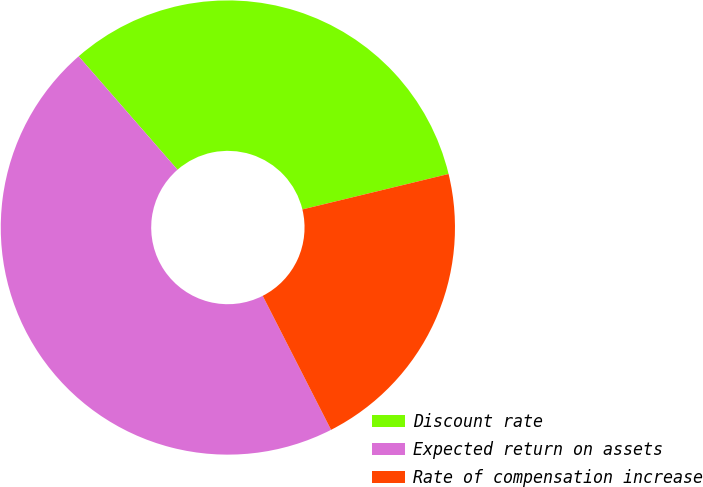Convert chart to OTSL. <chart><loc_0><loc_0><loc_500><loc_500><pie_chart><fcel>Discount rate<fcel>Expected return on assets<fcel>Rate of compensation increase<nl><fcel>32.62%<fcel>46.1%<fcel>21.28%<nl></chart> 